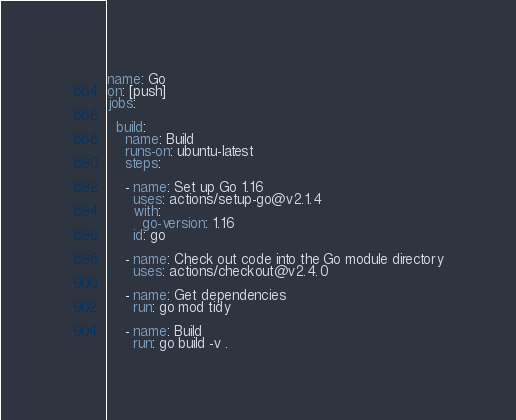Convert code to text. <code><loc_0><loc_0><loc_500><loc_500><_YAML_>name: Go
on: [push]
jobs:

  build:
    name: Build
    runs-on: ubuntu-latest
    steps:

    - name: Set up Go 1.16
      uses: actions/setup-go@v2.1.4
      with:
        go-version: 1.16
      id: go

    - name: Check out code into the Go module directory
      uses: actions/checkout@v2.4.0

    - name: Get dependencies
      run: go mod tidy

    - name: Build
      run: go build -v .
</code> 